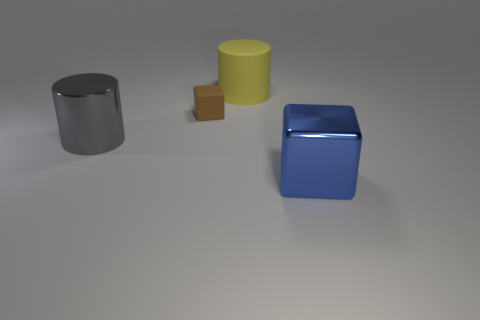Is there anything else that is the same size as the brown object?
Provide a short and direct response. No. There is a metallic cube; is its size the same as the cylinder that is to the left of the brown object?
Provide a succinct answer. Yes. How many other objects are the same material as the gray object?
Provide a succinct answer. 1. What number of objects are cylinders that are to the left of the tiny brown rubber object or cylinders in front of the small object?
Your answer should be very brief. 1. What material is the yellow object that is the same shape as the gray object?
Your response must be concise. Rubber. Are there any tiny brown things?
Your response must be concise. Yes. What size is the thing that is in front of the large rubber cylinder and behind the gray object?
Give a very brief answer. Small. What shape is the tiny brown matte object?
Keep it short and to the point. Cube. There is a metallic thing that is right of the big gray thing; are there any tiny matte blocks that are to the right of it?
Provide a succinct answer. No. There is a gray cylinder that is the same size as the yellow matte thing; what is it made of?
Offer a terse response. Metal. 